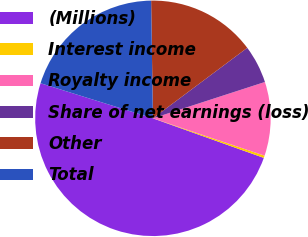<chart> <loc_0><loc_0><loc_500><loc_500><pie_chart><fcel>(Millions)<fcel>Interest income<fcel>Royalty income<fcel>Share of net earnings (loss)<fcel>Other<fcel>Total<nl><fcel>49.36%<fcel>0.32%<fcel>10.13%<fcel>5.22%<fcel>15.03%<fcel>19.94%<nl></chart> 